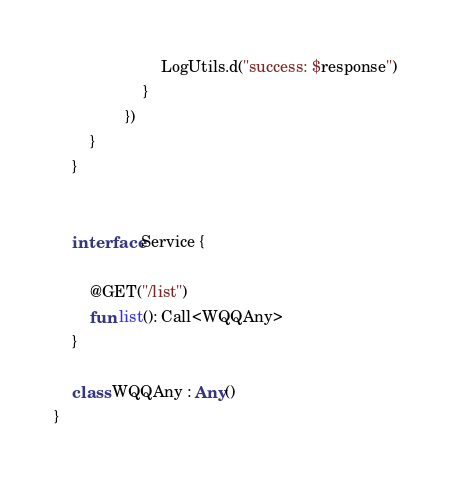Convert code to text. <code><loc_0><loc_0><loc_500><loc_500><_Kotlin_>                        LogUtils.d("success: $response")
                    }
                })
        }
    }


    interface Service {

        @GET("/list")
        fun list(): Call<WQQAny>
    }

    class WQQAny : Any()
}

</code> 